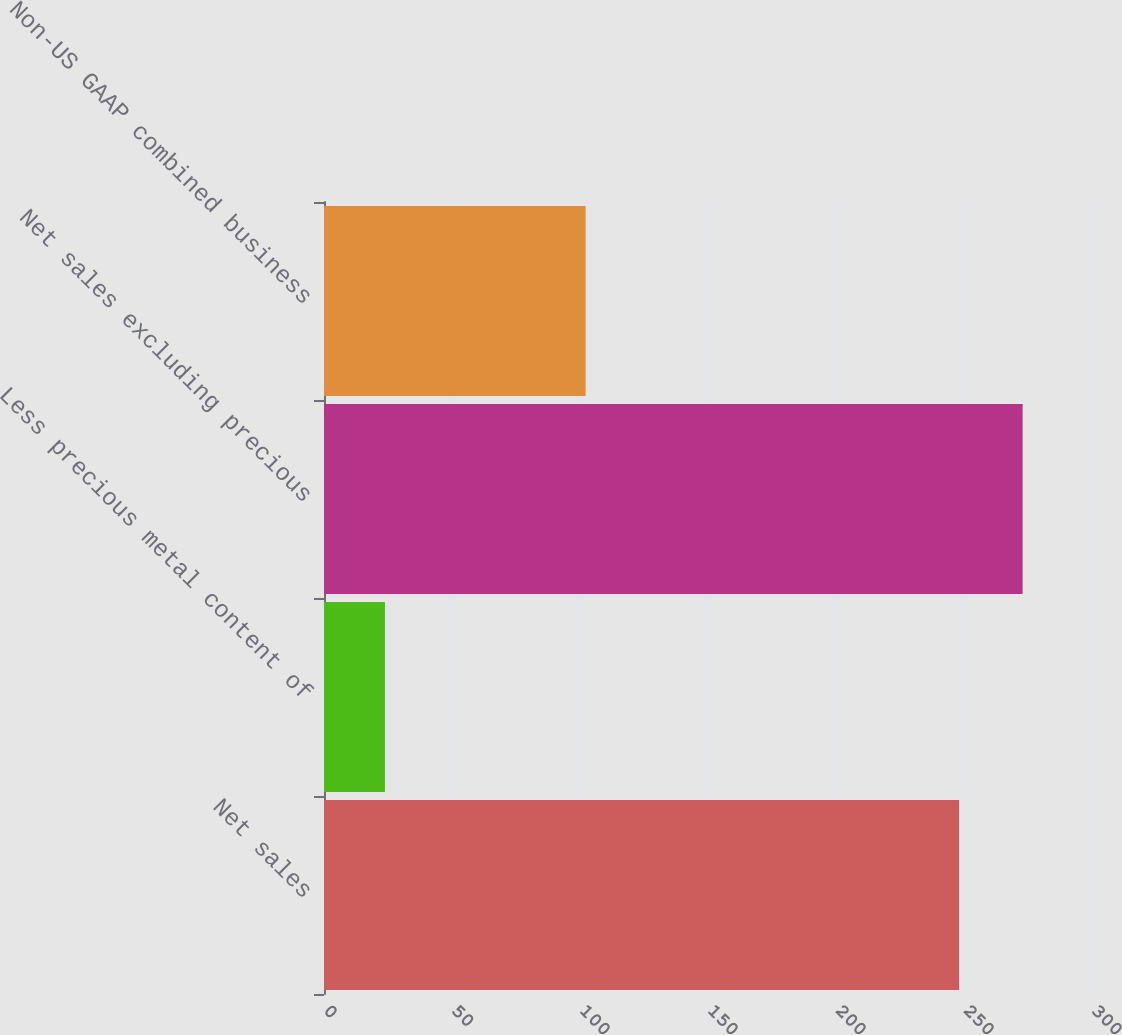<chart> <loc_0><loc_0><loc_500><loc_500><bar_chart><fcel>Net sales<fcel>Less precious metal content of<fcel>Net sales excluding precious<fcel>Non-US GAAP combined business<nl><fcel>248.1<fcel>23.8<fcel>272.91<fcel>102.2<nl></chart> 